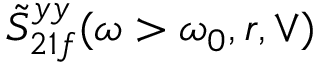Convert formula to latex. <formula><loc_0><loc_0><loc_500><loc_500>\tilde { S } _ { 2 1 f } ^ { y y } ( \omega > \omega _ { 0 } , r , \vee )</formula> 